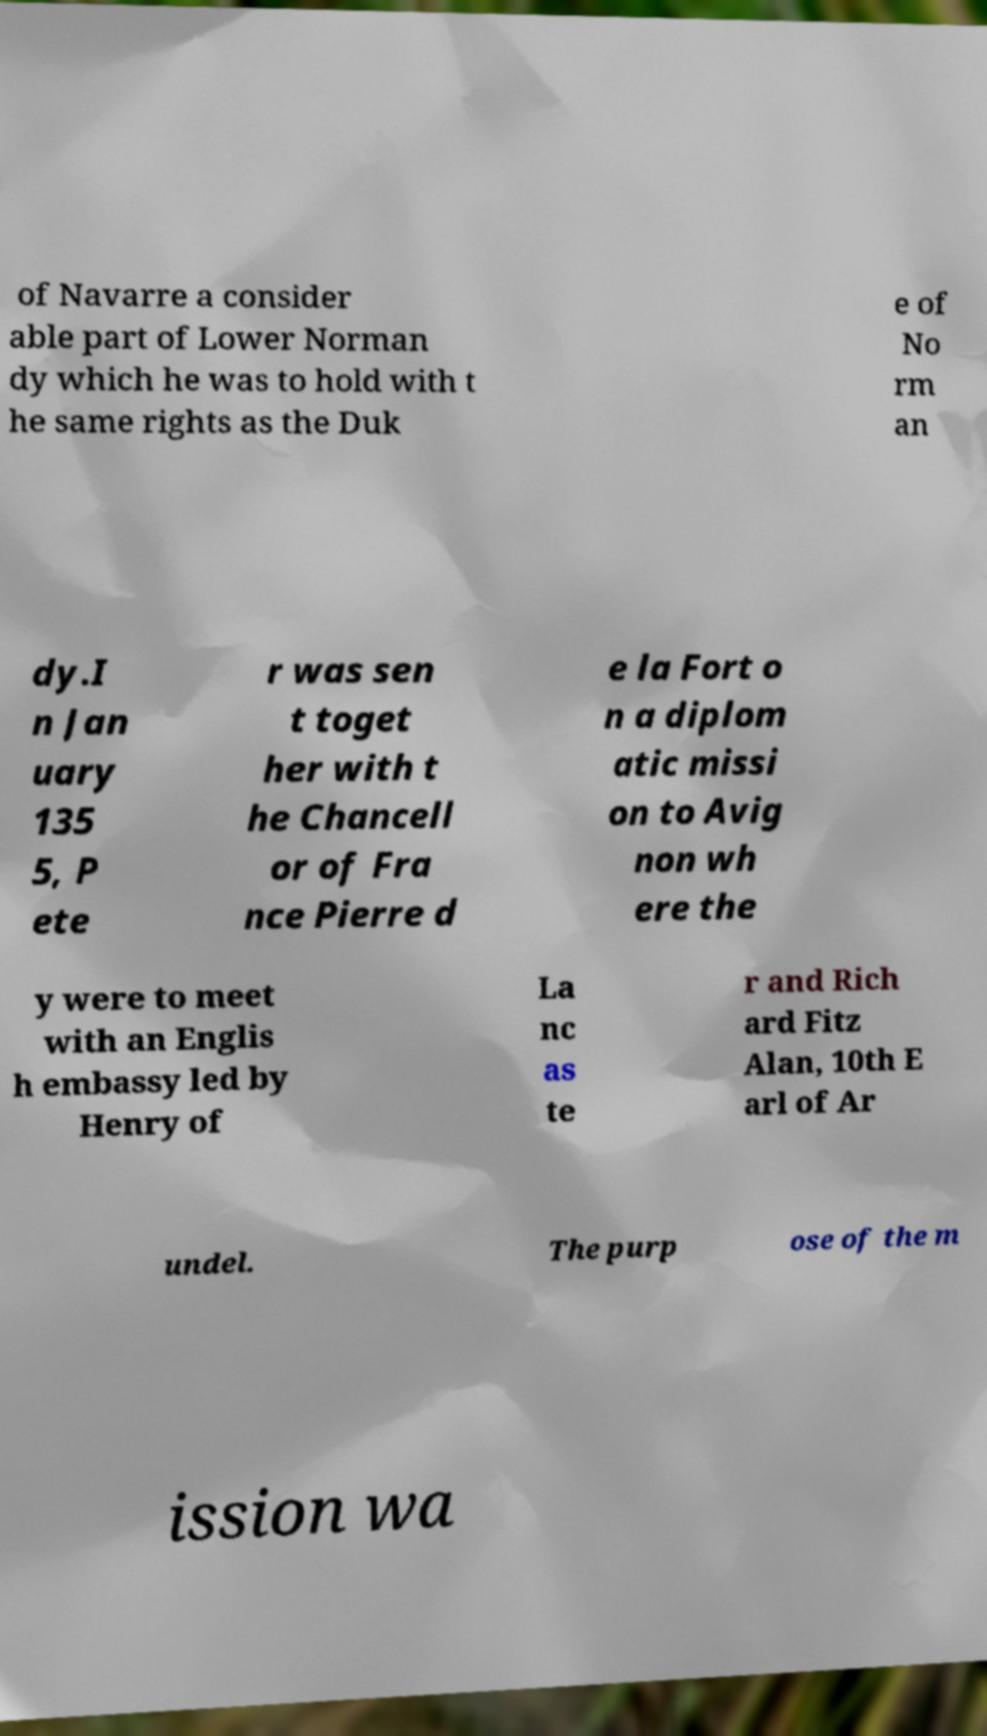Could you assist in decoding the text presented in this image and type it out clearly? of Navarre a consider able part of Lower Norman dy which he was to hold with t he same rights as the Duk e of No rm an dy.I n Jan uary 135 5, P ete r was sen t toget her with t he Chancell or of Fra nce Pierre d e la Fort o n a diplom atic missi on to Avig non wh ere the y were to meet with an Englis h embassy led by Henry of La nc as te r and Rich ard Fitz Alan, 10th E arl of Ar undel. The purp ose of the m ission wa 